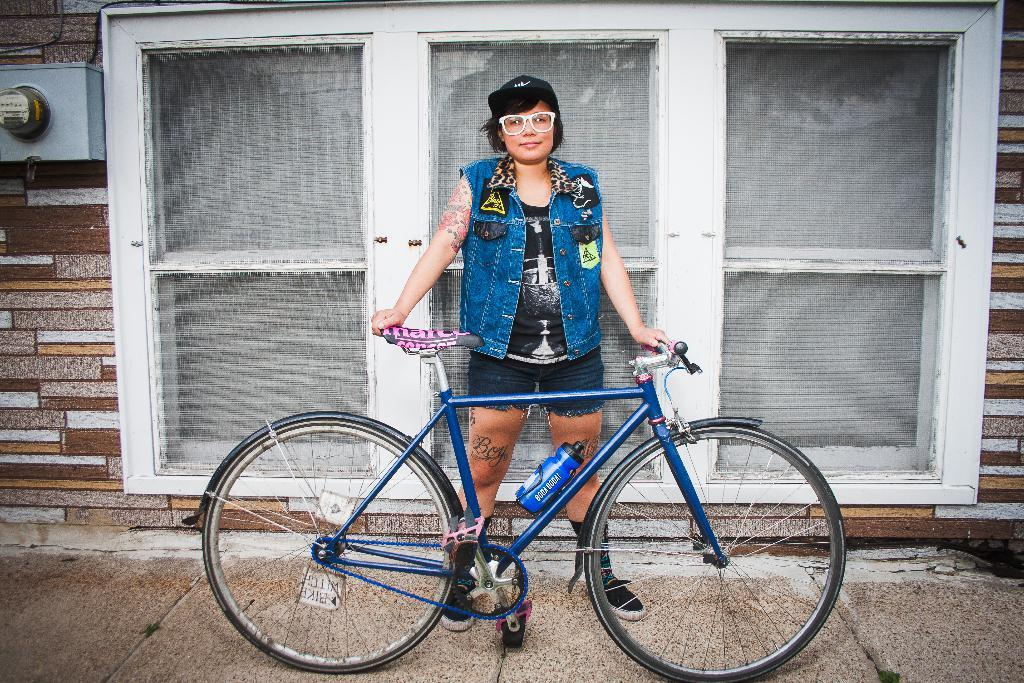What is the main subject of the image? There is a person in the image. What is the person doing in the image? The person is standing and holding a bicycle. What can be seen in the background of the image? There is a wall and glass windows visible in the background. What type of instrument is the person playing in the image? There is no instrument present in the image; the person is holding a bicycle. What type of coaching advice can be seen in the image? There is no coach or coaching advice present in the image. 